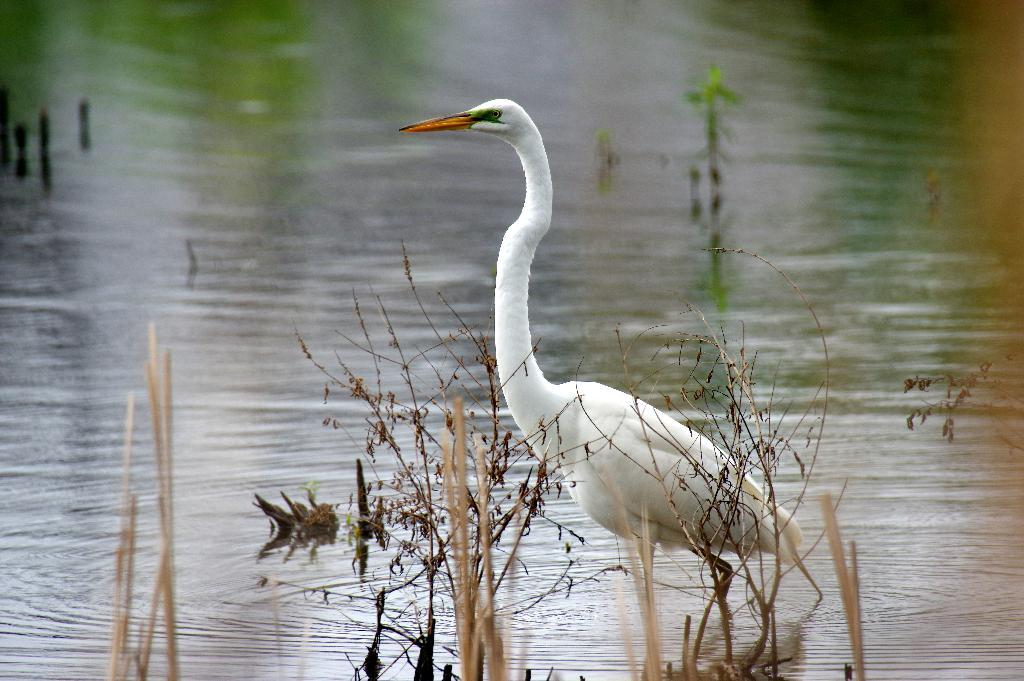What type of bird is in the picture? There is a crane bird in the picture. What color is the crane bird? The crane bird is white in color. Where is the crane bird located in relation to the water? The crane bird is near the water. What type of vegetation is near the crane bird? There are dried plants beside the crane bird. What story is the crane bird telling in the image? There is no indication in the image that the crane bird is telling a story. 